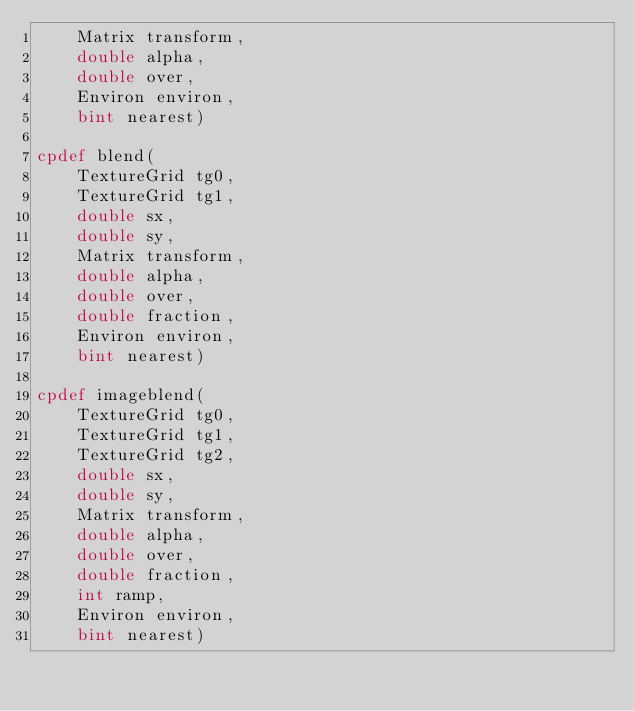Convert code to text. <code><loc_0><loc_0><loc_500><loc_500><_Cython_>    Matrix transform,
    double alpha,
    double over,
    Environ environ,
    bint nearest)

cpdef blend(
    TextureGrid tg0,
    TextureGrid tg1,
    double sx,
    double sy,
    Matrix transform,
    double alpha,
    double over,
    double fraction,
    Environ environ,
    bint nearest)

cpdef imageblend(
    TextureGrid tg0,
    TextureGrid tg1,
    TextureGrid tg2,
    double sx,
    double sy,
    Matrix transform,
    double alpha,
    double over,
    double fraction,
    int ramp,
    Environ environ,
    bint nearest)
</code> 